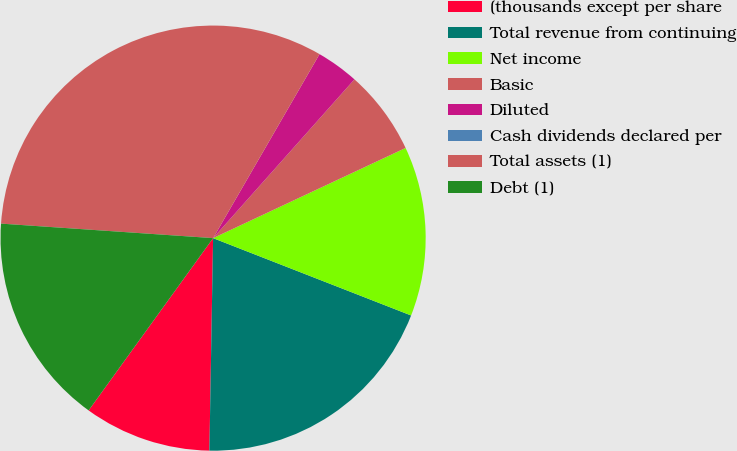Convert chart. <chart><loc_0><loc_0><loc_500><loc_500><pie_chart><fcel>(thousands except per share<fcel>Total revenue from continuing<fcel>Net income<fcel>Basic<fcel>Diluted<fcel>Cash dividends declared per<fcel>Total assets (1)<fcel>Debt (1)<nl><fcel>9.68%<fcel>19.35%<fcel>12.9%<fcel>6.45%<fcel>3.23%<fcel>0.0%<fcel>32.26%<fcel>16.13%<nl></chart> 